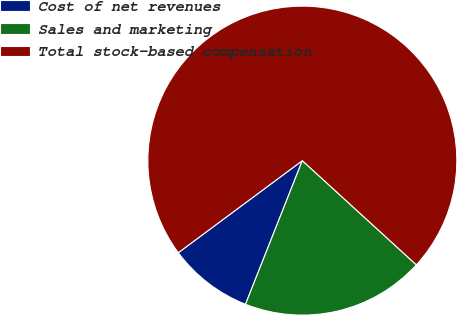Convert chart. <chart><loc_0><loc_0><loc_500><loc_500><pie_chart><fcel>Cost of net revenues<fcel>Sales and marketing<fcel>Total stock-based compensation<nl><fcel>8.84%<fcel>19.21%<fcel>71.95%<nl></chart> 